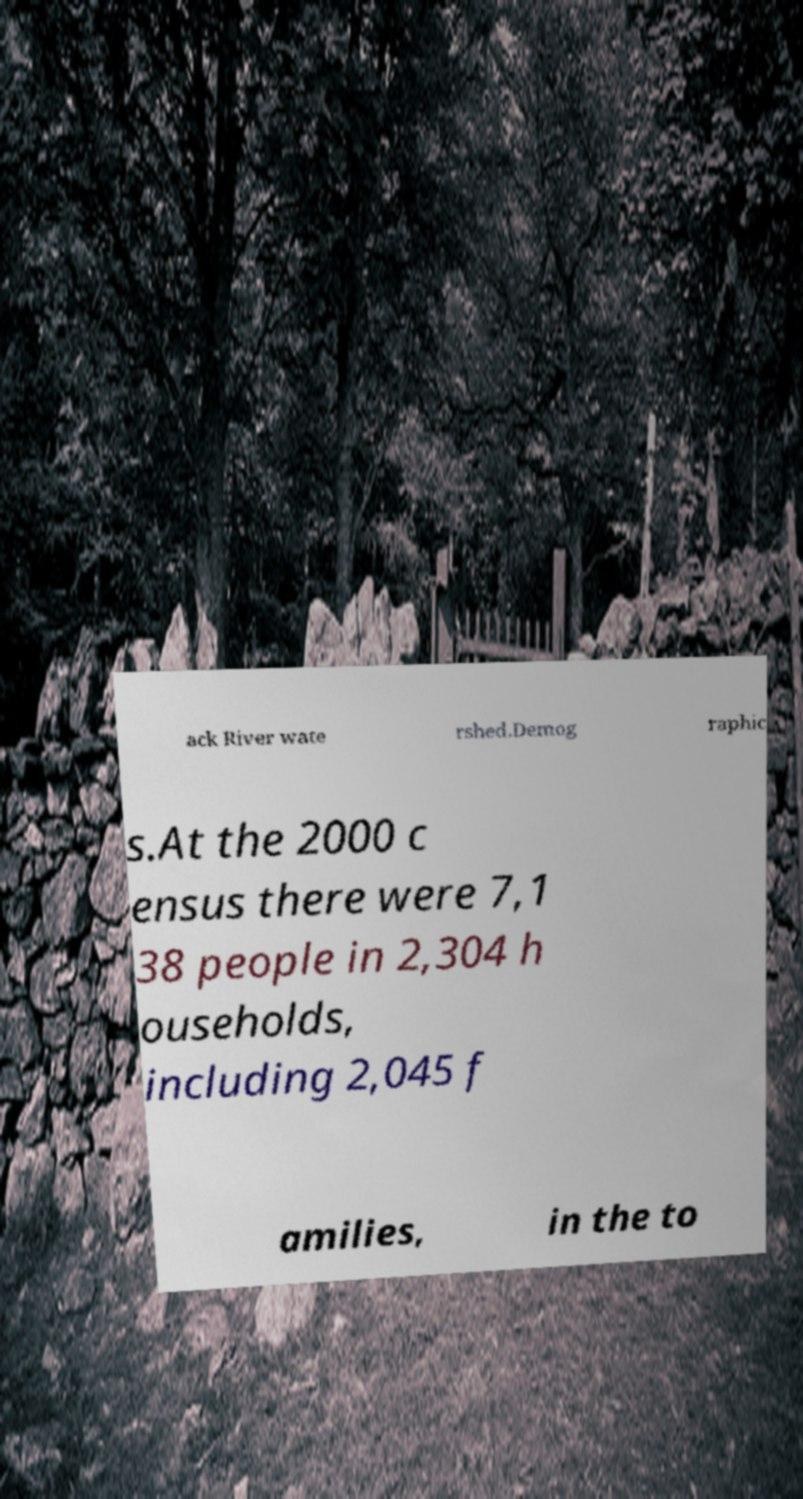What messages or text are displayed in this image? I need them in a readable, typed format. ack River wate rshed.Demog raphic s.At the 2000 c ensus there were 7,1 38 people in 2,304 h ouseholds, including 2,045 f amilies, in the to 